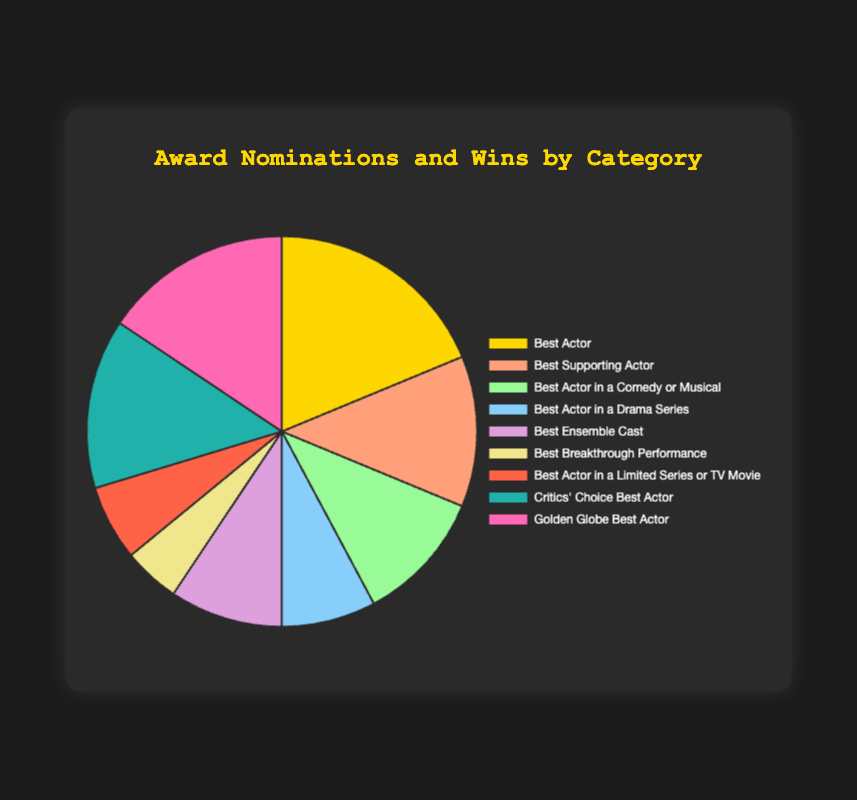What category has the highest number of nominations? The "Best Actor" category has the highest number of nominations, which is 12.
Answer: Best Actor Which category has more wins, "Best Supporting Actor" or "Golden Globe Best Actor"? The "Golden Globe Best Actor" category has 3 wins, while the "Best Supporting Actor" category has 3 wins as well, so they have an equal number of wins.
Answer: Equal What is the total number of nominations across all categories? Sum the nominations from each category: 12 + 8 + 7 + 5 + 6 + 3 + 4 + 9 + 10 = 64.
Answer: 64 How many more wins does the "Critics' Choice Best Actor" category have compared to the "Best Breakthrough Performance" category? "Critics' Choice Best Actor" has 4 wins and "Best Breakthrough Performance" has 1 win. The difference is 4 - 1 = 3.
Answer: 3 Which category has the fewest nominations, and how many are there? The "Best Breakthrough Performance" category has the fewest nominations, which is 3.
Answer: Best Breakthrough Performance, 3 What is the ratio of wins to nominations in the "Best Actor" category? The ratio is the number of wins (5) to the number of nominations (12), which simplifies to 5:12.
Answer: 5:12 Which category has a higher win ratio, "Best Actor in a Comedy or Musical" or "Best Ensemble Cast"? For "Best Actor in a Comedy or Musical", the win ratio is 2/7. For "Best Ensemble Cast", the win ratio is 2/6. "Best Ensemble Cast" has a win ratio of 1/3, which is higher than 2/7.
Answer: Best Ensemble Cast If we combine all "Best Actor"-type categories, what is the total number of nominations and total number of wins? Combine nominations and wins from "Best Actor" (12, 5), "Best Actor in a Comedy or Musical" (7, 2), "Best Actor in a Drama Series" (5, 1), "Best Actor in a Limited Series or TV Movie" (4, 1), "Critics' Choice Best Actor" (9, 4), "Golden Globe Best Actor" (10, 3): Nominations = 12+7+5+4+9+10 = 47, Wins = 5+2+1+1+4+3 = 16.
Answer: 47 nominations, 16 wins How many categories have 1 win each? "Best Actor in a Drama Series", "Best Breakthrough Performance", and "Best Actor in a Limited Series or TV Movie" each have 1 win, so there are 3 categories.
Answer: 3 categories 